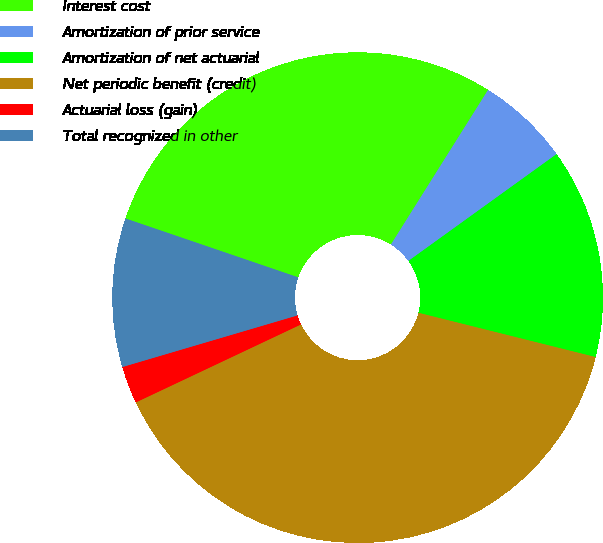Convert chart to OTSL. <chart><loc_0><loc_0><loc_500><loc_500><pie_chart><fcel>Interest cost<fcel>Amortization of prior service<fcel>Amortization of net actuarial<fcel>Net periodic benefit (credit)<fcel>Actuarial loss (gain)<fcel>Total recognized in other<nl><fcel>28.7%<fcel>6.13%<fcel>13.84%<fcel>39.08%<fcel>2.46%<fcel>9.79%<nl></chart> 